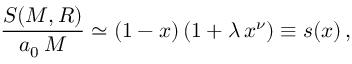<formula> <loc_0><loc_0><loc_500><loc_500>\frac { S ( M , R ) } { a _ { 0 } \, M } \simeq ( 1 - x ) \, ( 1 + \lambda \, x ^ { \nu } ) \equiv s ( x ) \, ,</formula> 